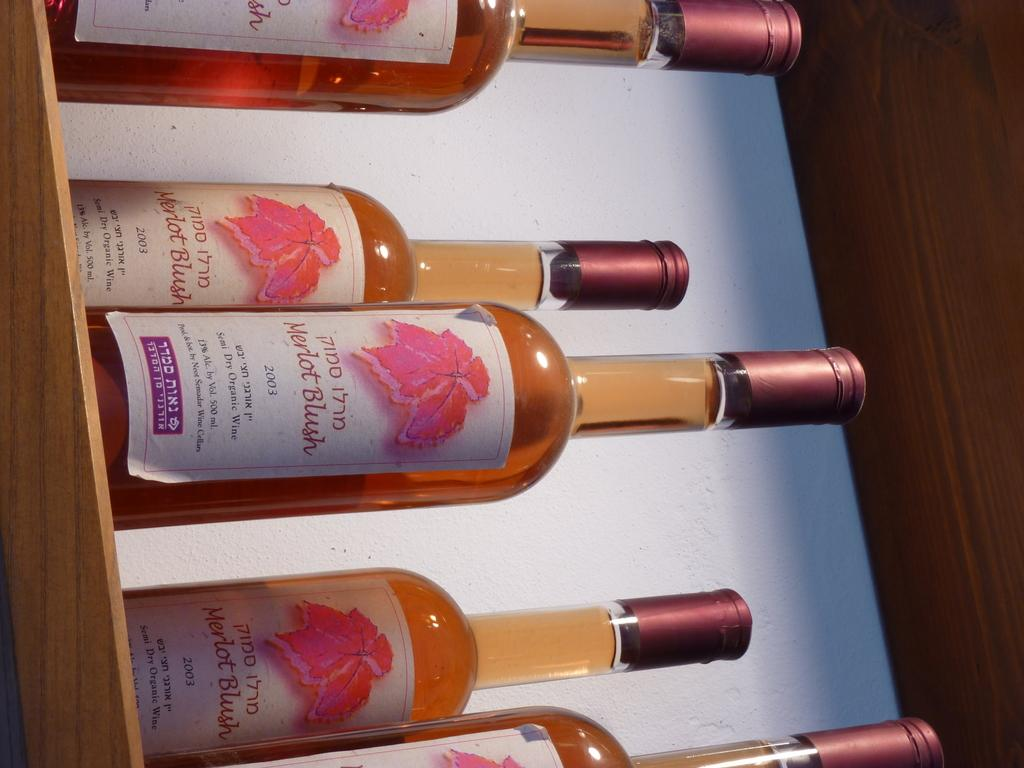<image>
Render a clear and concise summary of the photo. Five bottles of merlot blush sitting on the shelf. 